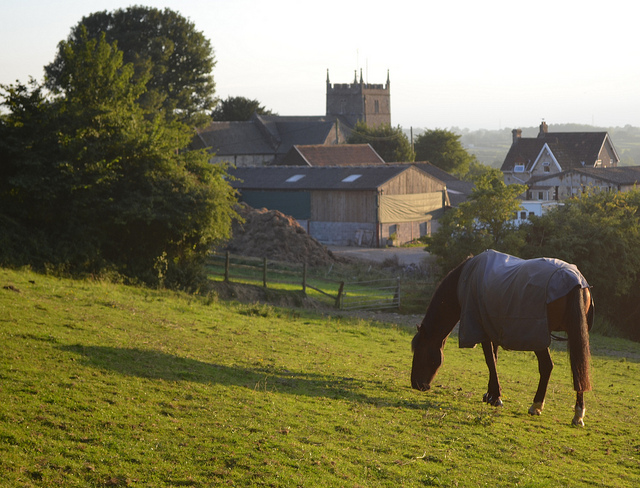<image>What kind of wire is pictured? There is no wire pictured in the image. What kind of horse is this? I don't know what kind of horse this is. It could be a thoroughbred, appaloosa, or a racing horse. What kind of wire is pictured? I don't know what kind of wire is pictured. It can be seen 'telephone', 'fence', 'barbed wire' or none. What kind of horse is this? I am not sure what kind of horse is in the image. It can be either brown, thoroughbred, appaloosa or racing. 